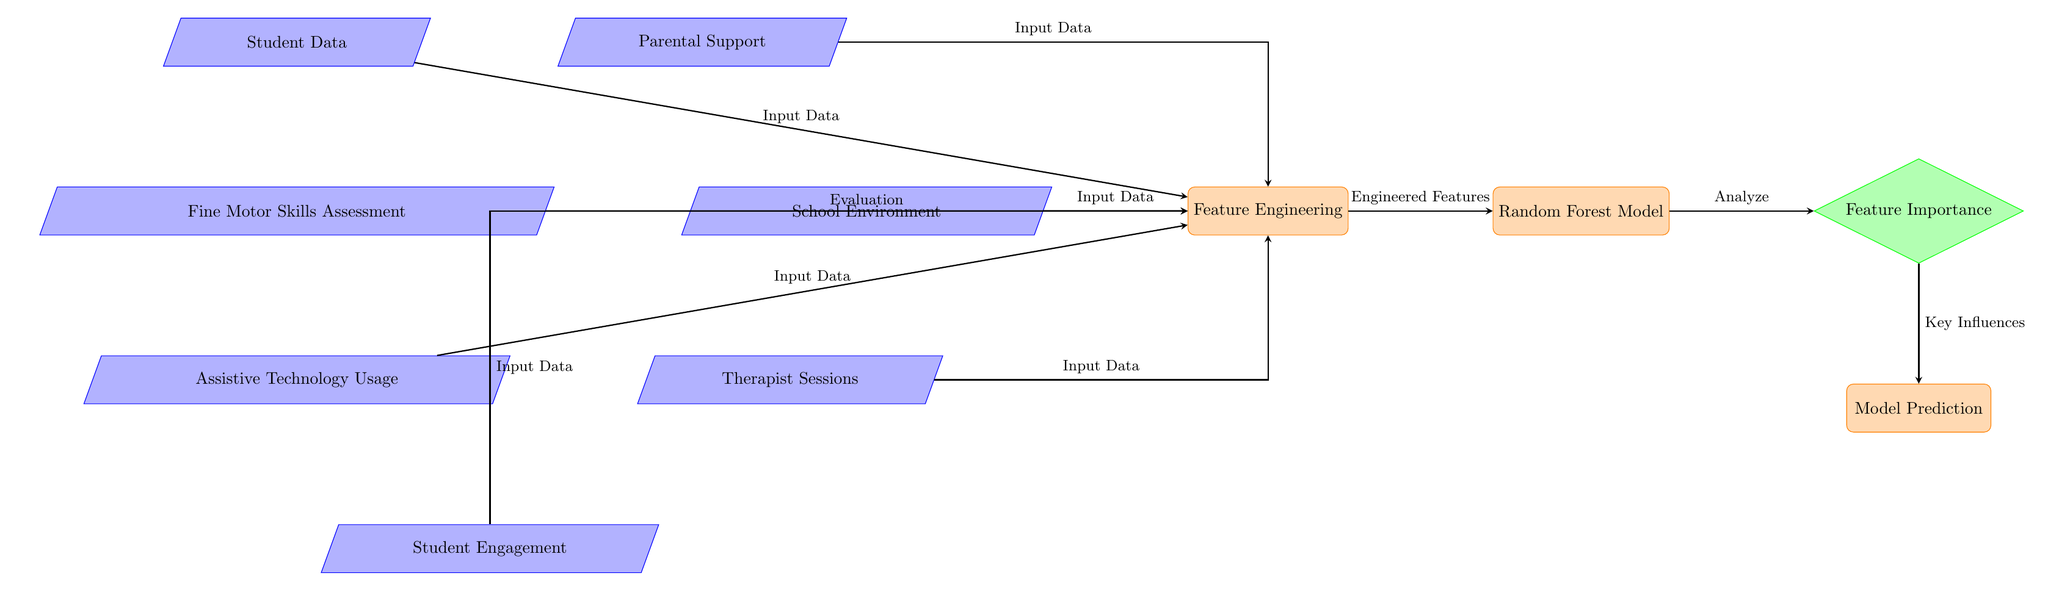What is the first node in the diagram? The first node in the diagram, located at the top, is labeled "Student Data." It is the starting point of the flow before presenting any other inputs.
Answer: Student Data How many inputs contribute to Feature Engineering? There are six sources of input data that feed into the "Feature Engineering" process: Student Data, Fine Motor Skills Assessment, Assistive Technology Usage, Parental Support, School Environment, and Therapist Sessions. This can be counted by observing the arrows directed towards the "Feature Engineering" node.
Answer: 6 What type of model is used in the diagram? The model used, as indicated in the labeled node, is a "Random Forest Model." This specifies the algorithm employed in analyzing the engineered features.
Answer: Random Forest Model What is the output of the Feature Importance node? The output of the "Feature Importance" node is labeled as "Key Influences." This indicates that the model identifies and outputs the most crucial factors influencing the data being analyzed.
Answer: Key Influences Which node represents the assessment of fine motor skills? The node that represents the assessment of fine motor skills is labeled "Fine Motor Skills Assessment." This is one of the input data sources needed for feature engineering.
Answer: Fine Motor Skills Assessment Which node is connected to both the Student Engagement and Assistive Technology Usage? The node that connects to both of these inputs is the "Feature Engineering" node. This shows that both Student Engagement and Assistive Technology Usage contribute data for processing.
Answer: Feature Engineering What are the nodes adjacent to the 'Feature Importance' decision node? The node directly above 'Feature Importance' is "Random Forest Model," and the node below is "Model Prediction." This shows the flow of analysis and subsequent prediction outcomes derived from the features' importance.
Answer: Random Forest Model, Model Prediction Which factors influence the model among the input data? The factors influencing the model among the input data include Student Data, Fine Motor Skills Assessment, Assistive Technology Usage, Parental Support, School Environment, Therapist Sessions, and Student Engagement. Each of these inputs is necessary for understanding and predicting student progress in fine motor skills.
Answer: Student Data, Fine Motor Skills Assessment, Assistive Technology Usage, Parental Support, School Environment, Therapist Sessions, Student Engagement 